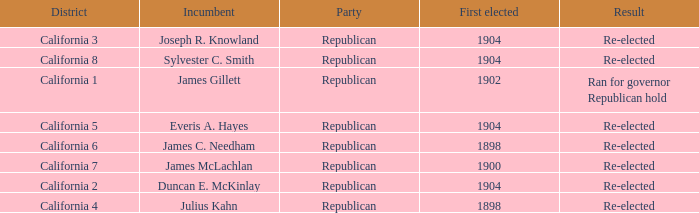What's the highest First Elected with a Result of Re-elected and DIstrict of California 5? 1904.0. 